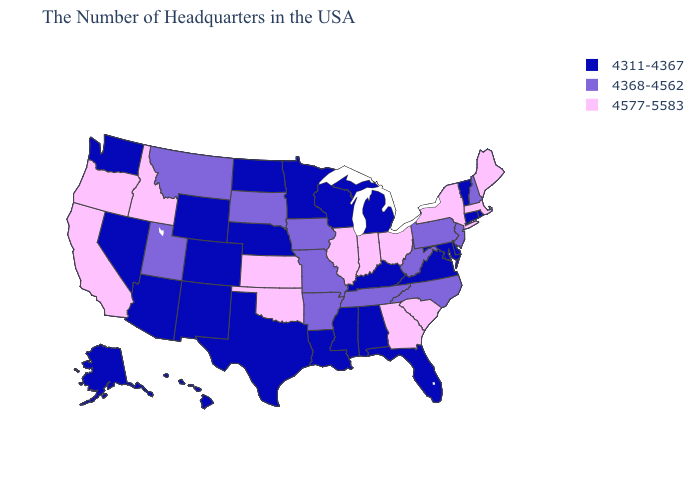What is the value of Florida?
Be succinct. 4311-4367. What is the value of Utah?
Short answer required. 4368-4562. Name the states that have a value in the range 4577-5583?
Answer briefly. Maine, Massachusetts, New York, South Carolina, Ohio, Georgia, Indiana, Illinois, Kansas, Oklahoma, Idaho, California, Oregon. Name the states that have a value in the range 4311-4367?
Quick response, please. Rhode Island, Vermont, Connecticut, Delaware, Maryland, Virginia, Florida, Michigan, Kentucky, Alabama, Wisconsin, Mississippi, Louisiana, Minnesota, Nebraska, Texas, North Dakota, Wyoming, Colorado, New Mexico, Arizona, Nevada, Washington, Alaska, Hawaii. What is the value of Nevada?
Keep it brief. 4311-4367. Which states have the highest value in the USA?
Be succinct. Maine, Massachusetts, New York, South Carolina, Ohio, Georgia, Indiana, Illinois, Kansas, Oklahoma, Idaho, California, Oregon. Name the states that have a value in the range 4311-4367?
Be succinct. Rhode Island, Vermont, Connecticut, Delaware, Maryland, Virginia, Florida, Michigan, Kentucky, Alabama, Wisconsin, Mississippi, Louisiana, Minnesota, Nebraska, Texas, North Dakota, Wyoming, Colorado, New Mexico, Arizona, Nevada, Washington, Alaska, Hawaii. What is the value of Illinois?
Concise answer only. 4577-5583. Among the states that border North Carolina , which have the highest value?
Short answer required. South Carolina, Georgia. What is the value of Nevada?
Keep it brief. 4311-4367. Does New Jersey have the lowest value in the Northeast?
Write a very short answer. No. Among the states that border Colorado , does Utah have the highest value?
Keep it brief. No. Among the states that border Wisconsin , does Minnesota have the lowest value?
Be succinct. Yes. Among the states that border Texas , does New Mexico have the lowest value?
Concise answer only. Yes. 